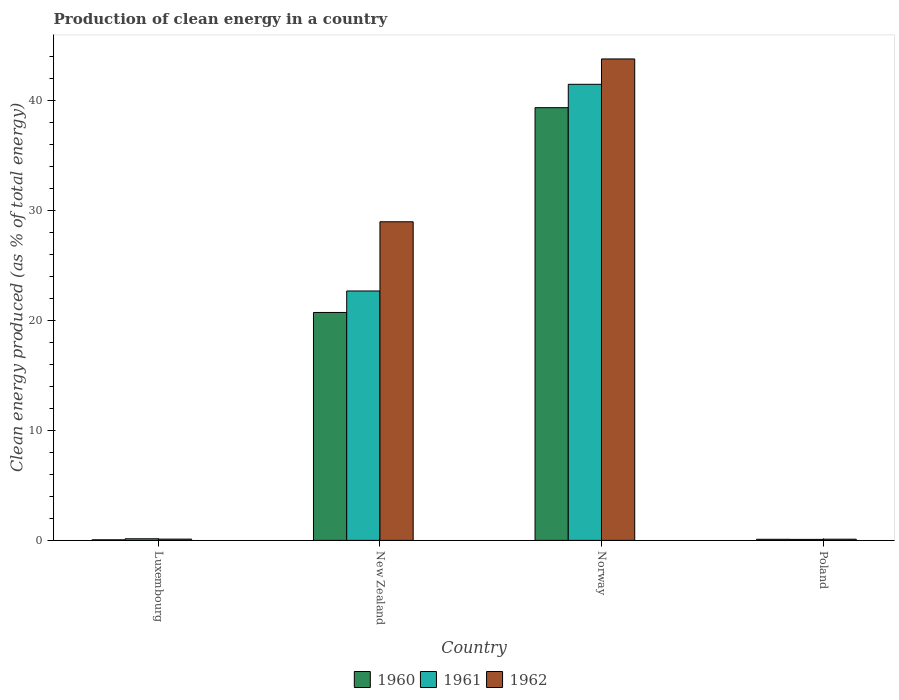How many different coloured bars are there?
Offer a very short reply. 3. Are the number of bars per tick equal to the number of legend labels?
Offer a very short reply. Yes. Are the number of bars on each tick of the X-axis equal?
Your answer should be very brief. Yes. How many bars are there on the 2nd tick from the left?
Offer a very short reply. 3. How many bars are there on the 1st tick from the right?
Your response must be concise. 3. What is the percentage of clean energy produced in 1961 in Norway?
Give a very brief answer. 41.46. Across all countries, what is the maximum percentage of clean energy produced in 1960?
Offer a very short reply. 39.34. Across all countries, what is the minimum percentage of clean energy produced in 1961?
Make the answer very short. 0.09. In which country was the percentage of clean energy produced in 1962 maximum?
Give a very brief answer. Norway. In which country was the percentage of clean energy produced in 1961 minimum?
Your answer should be compact. Poland. What is the total percentage of clean energy produced in 1960 in the graph?
Your answer should be compact. 60.21. What is the difference between the percentage of clean energy produced in 1961 in New Zealand and that in Poland?
Offer a terse response. 22.58. What is the difference between the percentage of clean energy produced in 1962 in Poland and the percentage of clean energy produced in 1961 in Luxembourg?
Keep it short and to the point. -0.04. What is the average percentage of clean energy produced in 1960 per country?
Your answer should be compact. 15.05. What is the difference between the percentage of clean energy produced of/in 1962 and percentage of clean energy produced of/in 1960 in Norway?
Provide a short and direct response. 4.43. What is the ratio of the percentage of clean energy produced in 1961 in Luxembourg to that in Norway?
Provide a short and direct response. 0. Is the difference between the percentage of clean energy produced in 1962 in Luxembourg and Norway greater than the difference between the percentage of clean energy produced in 1960 in Luxembourg and Norway?
Give a very brief answer. No. What is the difference between the highest and the second highest percentage of clean energy produced in 1962?
Your response must be concise. -43.65. What is the difference between the highest and the lowest percentage of clean energy produced in 1962?
Provide a short and direct response. 43.66. Is it the case that in every country, the sum of the percentage of clean energy produced in 1961 and percentage of clean energy produced in 1962 is greater than the percentage of clean energy produced in 1960?
Offer a very short reply. Yes. Are all the bars in the graph horizontal?
Provide a short and direct response. No. What is the difference between two consecutive major ticks on the Y-axis?
Your answer should be very brief. 10. Are the values on the major ticks of Y-axis written in scientific E-notation?
Your answer should be compact. No. Does the graph contain any zero values?
Ensure brevity in your answer.  No. Does the graph contain grids?
Keep it short and to the point. No. Where does the legend appear in the graph?
Your response must be concise. Bottom center. What is the title of the graph?
Provide a short and direct response. Production of clean energy in a country. Does "1998" appear as one of the legend labels in the graph?
Provide a short and direct response. No. What is the label or title of the Y-axis?
Provide a short and direct response. Clean energy produced (as % of total energy). What is the Clean energy produced (as % of total energy) of 1960 in Luxembourg?
Keep it short and to the point. 0.05. What is the Clean energy produced (as % of total energy) in 1961 in Luxembourg?
Your answer should be very brief. 0.15. What is the Clean energy produced (as % of total energy) in 1962 in Luxembourg?
Keep it short and to the point. 0.12. What is the Clean energy produced (as % of total energy) of 1960 in New Zealand?
Ensure brevity in your answer.  20.72. What is the Clean energy produced (as % of total energy) in 1961 in New Zealand?
Offer a terse response. 22.67. What is the Clean energy produced (as % of total energy) of 1962 in New Zealand?
Your answer should be very brief. 28.96. What is the Clean energy produced (as % of total energy) of 1960 in Norway?
Make the answer very short. 39.34. What is the Clean energy produced (as % of total energy) in 1961 in Norway?
Your response must be concise. 41.46. What is the Clean energy produced (as % of total energy) of 1962 in Norway?
Provide a succinct answer. 43.77. What is the Clean energy produced (as % of total energy) in 1960 in Poland?
Ensure brevity in your answer.  0.1. What is the Clean energy produced (as % of total energy) in 1961 in Poland?
Offer a terse response. 0.09. What is the Clean energy produced (as % of total energy) of 1962 in Poland?
Provide a short and direct response. 0.11. Across all countries, what is the maximum Clean energy produced (as % of total energy) of 1960?
Offer a very short reply. 39.34. Across all countries, what is the maximum Clean energy produced (as % of total energy) of 1961?
Your response must be concise. 41.46. Across all countries, what is the maximum Clean energy produced (as % of total energy) of 1962?
Give a very brief answer. 43.77. Across all countries, what is the minimum Clean energy produced (as % of total energy) in 1960?
Give a very brief answer. 0.05. Across all countries, what is the minimum Clean energy produced (as % of total energy) in 1961?
Provide a short and direct response. 0.09. Across all countries, what is the minimum Clean energy produced (as % of total energy) in 1962?
Your answer should be compact. 0.11. What is the total Clean energy produced (as % of total energy) of 1960 in the graph?
Your response must be concise. 60.21. What is the total Clean energy produced (as % of total energy) of 1961 in the graph?
Offer a terse response. 64.37. What is the total Clean energy produced (as % of total energy) of 1962 in the graph?
Ensure brevity in your answer.  72.95. What is the difference between the Clean energy produced (as % of total energy) of 1960 in Luxembourg and that in New Zealand?
Provide a short and direct response. -20.67. What is the difference between the Clean energy produced (as % of total energy) of 1961 in Luxembourg and that in New Zealand?
Offer a terse response. -22.53. What is the difference between the Clean energy produced (as % of total energy) of 1962 in Luxembourg and that in New Zealand?
Make the answer very short. -28.85. What is the difference between the Clean energy produced (as % of total energy) of 1960 in Luxembourg and that in Norway?
Provide a succinct answer. -39.28. What is the difference between the Clean energy produced (as % of total energy) in 1961 in Luxembourg and that in Norway?
Offer a terse response. -41.31. What is the difference between the Clean energy produced (as % of total energy) in 1962 in Luxembourg and that in Norway?
Make the answer very short. -43.65. What is the difference between the Clean energy produced (as % of total energy) of 1960 in Luxembourg and that in Poland?
Your answer should be compact. -0.05. What is the difference between the Clean energy produced (as % of total energy) in 1961 in Luxembourg and that in Poland?
Your response must be concise. 0.06. What is the difference between the Clean energy produced (as % of total energy) of 1962 in Luxembourg and that in Poland?
Your response must be concise. 0.01. What is the difference between the Clean energy produced (as % of total energy) in 1960 in New Zealand and that in Norway?
Offer a very short reply. -18.62. What is the difference between the Clean energy produced (as % of total energy) in 1961 in New Zealand and that in Norway?
Your response must be concise. -18.79. What is the difference between the Clean energy produced (as % of total energy) of 1962 in New Zealand and that in Norway?
Provide a succinct answer. -14.8. What is the difference between the Clean energy produced (as % of total energy) of 1960 in New Zealand and that in Poland?
Make the answer very short. 20.62. What is the difference between the Clean energy produced (as % of total energy) of 1961 in New Zealand and that in Poland?
Offer a terse response. 22.58. What is the difference between the Clean energy produced (as % of total energy) in 1962 in New Zealand and that in Poland?
Your answer should be very brief. 28.86. What is the difference between the Clean energy produced (as % of total energy) of 1960 in Norway and that in Poland?
Provide a succinct answer. 39.24. What is the difference between the Clean energy produced (as % of total energy) in 1961 in Norway and that in Poland?
Provide a short and direct response. 41.37. What is the difference between the Clean energy produced (as % of total energy) of 1962 in Norway and that in Poland?
Provide a short and direct response. 43.66. What is the difference between the Clean energy produced (as % of total energy) in 1960 in Luxembourg and the Clean energy produced (as % of total energy) in 1961 in New Zealand?
Give a very brief answer. -22.62. What is the difference between the Clean energy produced (as % of total energy) in 1960 in Luxembourg and the Clean energy produced (as % of total energy) in 1962 in New Zealand?
Offer a very short reply. -28.91. What is the difference between the Clean energy produced (as % of total energy) of 1961 in Luxembourg and the Clean energy produced (as % of total energy) of 1962 in New Zealand?
Make the answer very short. -28.82. What is the difference between the Clean energy produced (as % of total energy) in 1960 in Luxembourg and the Clean energy produced (as % of total energy) in 1961 in Norway?
Provide a short and direct response. -41.41. What is the difference between the Clean energy produced (as % of total energy) of 1960 in Luxembourg and the Clean energy produced (as % of total energy) of 1962 in Norway?
Your answer should be compact. -43.71. What is the difference between the Clean energy produced (as % of total energy) of 1961 in Luxembourg and the Clean energy produced (as % of total energy) of 1962 in Norway?
Provide a short and direct response. -43.62. What is the difference between the Clean energy produced (as % of total energy) of 1960 in Luxembourg and the Clean energy produced (as % of total energy) of 1961 in Poland?
Your answer should be compact. -0.04. What is the difference between the Clean energy produced (as % of total energy) in 1960 in Luxembourg and the Clean energy produced (as % of total energy) in 1962 in Poland?
Your response must be concise. -0.06. What is the difference between the Clean energy produced (as % of total energy) of 1961 in Luxembourg and the Clean energy produced (as % of total energy) of 1962 in Poland?
Offer a terse response. 0.04. What is the difference between the Clean energy produced (as % of total energy) of 1960 in New Zealand and the Clean energy produced (as % of total energy) of 1961 in Norway?
Your answer should be very brief. -20.74. What is the difference between the Clean energy produced (as % of total energy) in 1960 in New Zealand and the Clean energy produced (as % of total energy) in 1962 in Norway?
Offer a terse response. -23.05. What is the difference between the Clean energy produced (as % of total energy) in 1961 in New Zealand and the Clean energy produced (as % of total energy) in 1962 in Norway?
Ensure brevity in your answer.  -21.09. What is the difference between the Clean energy produced (as % of total energy) of 1960 in New Zealand and the Clean energy produced (as % of total energy) of 1961 in Poland?
Ensure brevity in your answer.  20.63. What is the difference between the Clean energy produced (as % of total energy) in 1960 in New Zealand and the Clean energy produced (as % of total energy) in 1962 in Poland?
Offer a terse response. 20.61. What is the difference between the Clean energy produced (as % of total energy) in 1961 in New Zealand and the Clean energy produced (as % of total energy) in 1962 in Poland?
Offer a terse response. 22.56. What is the difference between the Clean energy produced (as % of total energy) in 1960 in Norway and the Clean energy produced (as % of total energy) in 1961 in Poland?
Offer a very short reply. 39.24. What is the difference between the Clean energy produced (as % of total energy) of 1960 in Norway and the Clean energy produced (as % of total energy) of 1962 in Poland?
Offer a very short reply. 39.23. What is the difference between the Clean energy produced (as % of total energy) of 1961 in Norway and the Clean energy produced (as % of total energy) of 1962 in Poland?
Make the answer very short. 41.35. What is the average Clean energy produced (as % of total energy) of 1960 per country?
Give a very brief answer. 15.05. What is the average Clean energy produced (as % of total energy) in 1961 per country?
Ensure brevity in your answer.  16.09. What is the average Clean energy produced (as % of total energy) of 1962 per country?
Your answer should be very brief. 18.24. What is the difference between the Clean energy produced (as % of total energy) of 1960 and Clean energy produced (as % of total energy) of 1961 in Luxembourg?
Keep it short and to the point. -0.09. What is the difference between the Clean energy produced (as % of total energy) of 1960 and Clean energy produced (as % of total energy) of 1962 in Luxembourg?
Offer a terse response. -0.06. What is the difference between the Clean energy produced (as % of total energy) of 1961 and Clean energy produced (as % of total energy) of 1962 in Luxembourg?
Offer a terse response. 0.03. What is the difference between the Clean energy produced (as % of total energy) of 1960 and Clean energy produced (as % of total energy) of 1961 in New Zealand?
Your answer should be compact. -1.95. What is the difference between the Clean energy produced (as % of total energy) in 1960 and Clean energy produced (as % of total energy) in 1962 in New Zealand?
Give a very brief answer. -8.24. What is the difference between the Clean energy produced (as % of total energy) in 1961 and Clean energy produced (as % of total energy) in 1962 in New Zealand?
Keep it short and to the point. -6.29. What is the difference between the Clean energy produced (as % of total energy) in 1960 and Clean energy produced (as % of total energy) in 1961 in Norway?
Offer a very short reply. -2.12. What is the difference between the Clean energy produced (as % of total energy) in 1960 and Clean energy produced (as % of total energy) in 1962 in Norway?
Give a very brief answer. -4.43. What is the difference between the Clean energy produced (as % of total energy) of 1961 and Clean energy produced (as % of total energy) of 1962 in Norway?
Your response must be concise. -2.31. What is the difference between the Clean energy produced (as % of total energy) of 1960 and Clean energy produced (as % of total energy) of 1961 in Poland?
Ensure brevity in your answer.  0.01. What is the difference between the Clean energy produced (as % of total energy) in 1960 and Clean energy produced (as % of total energy) in 1962 in Poland?
Your response must be concise. -0.01. What is the difference between the Clean energy produced (as % of total energy) in 1961 and Clean energy produced (as % of total energy) in 1962 in Poland?
Ensure brevity in your answer.  -0.02. What is the ratio of the Clean energy produced (as % of total energy) in 1960 in Luxembourg to that in New Zealand?
Make the answer very short. 0. What is the ratio of the Clean energy produced (as % of total energy) in 1961 in Luxembourg to that in New Zealand?
Ensure brevity in your answer.  0.01. What is the ratio of the Clean energy produced (as % of total energy) of 1962 in Luxembourg to that in New Zealand?
Your answer should be compact. 0. What is the ratio of the Clean energy produced (as % of total energy) in 1960 in Luxembourg to that in Norway?
Ensure brevity in your answer.  0. What is the ratio of the Clean energy produced (as % of total energy) of 1961 in Luxembourg to that in Norway?
Your response must be concise. 0. What is the ratio of the Clean energy produced (as % of total energy) in 1962 in Luxembourg to that in Norway?
Offer a very short reply. 0. What is the ratio of the Clean energy produced (as % of total energy) in 1960 in Luxembourg to that in Poland?
Offer a terse response. 0.52. What is the ratio of the Clean energy produced (as % of total energy) of 1961 in Luxembourg to that in Poland?
Ensure brevity in your answer.  1.6. What is the ratio of the Clean energy produced (as % of total energy) of 1962 in Luxembourg to that in Poland?
Provide a short and direct response. 1.07. What is the ratio of the Clean energy produced (as % of total energy) of 1960 in New Zealand to that in Norway?
Your answer should be compact. 0.53. What is the ratio of the Clean energy produced (as % of total energy) in 1961 in New Zealand to that in Norway?
Provide a succinct answer. 0.55. What is the ratio of the Clean energy produced (as % of total energy) in 1962 in New Zealand to that in Norway?
Ensure brevity in your answer.  0.66. What is the ratio of the Clean energy produced (as % of total energy) of 1960 in New Zealand to that in Poland?
Offer a very short reply. 206.53. What is the ratio of the Clean energy produced (as % of total energy) of 1961 in New Zealand to that in Poland?
Make the answer very short. 247.72. What is the ratio of the Clean energy produced (as % of total energy) of 1962 in New Zealand to that in Poland?
Your response must be concise. 267.62. What is the ratio of the Clean energy produced (as % of total energy) of 1960 in Norway to that in Poland?
Ensure brevity in your answer.  392.08. What is the ratio of the Clean energy produced (as % of total energy) in 1961 in Norway to that in Poland?
Make the answer very short. 452.99. What is the ratio of the Clean energy produced (as % of total energy) of 1962 in Norway to that in Poland?
Your answer should be compact. 404.39. What is the difference between the highest and the second highest Clean energy produced (as % of total energy) of 1960?
Your answer should be very brief. 18.62. What is the difference between the highest and the second highest Clean energy produced (as % of total energy) in 1961?
Offer a terse response. 18.79. What is the difference between the highest and the second highest Clean energy produced (as % of total energy) of 1962?
Keep it short and to the point. 14.8. What is the difference between the highest and the lowest Clean energy produced (as % of total energy) in 1960?
Your answer should be compact. 39.28. What is the difference between the highest and the lowest Clean energy produced (as % of total energy) in 1961?
Your answer should be compact. 41.37. What is the difference between the highest and the lowest Clean energy produced (as % of total energy) in 1962?
Your answer should be very brief. 43.66. 